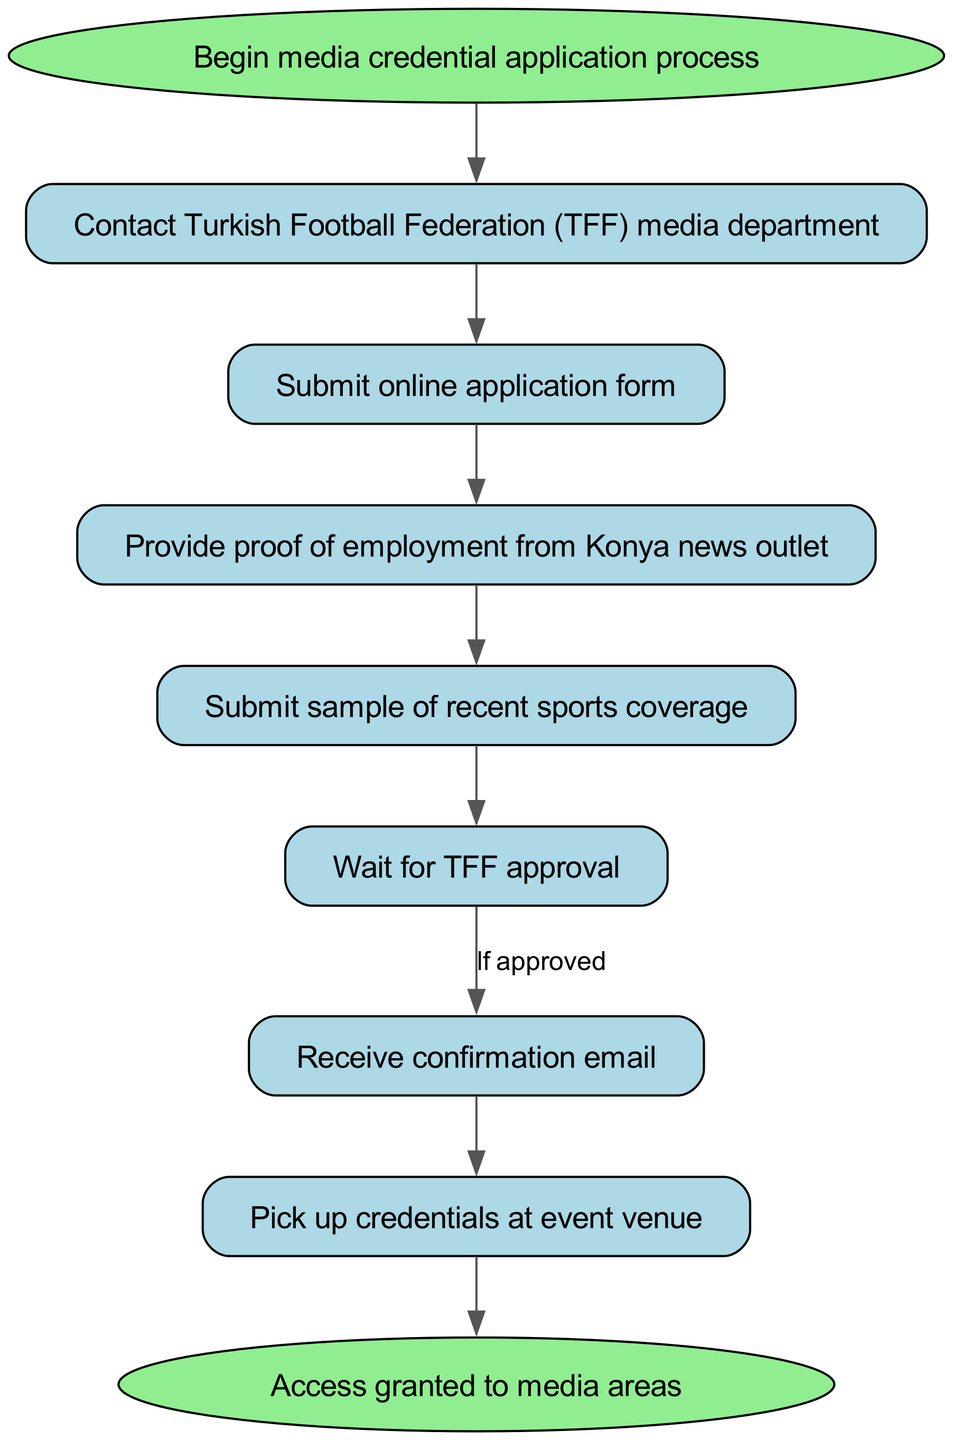What is the first step in the media credential application process? The first step is labeled "Begin media credential application process," which is represented by a starting node in the diagram.
Answer: Begin media credential application process How many nodes are there in the diagram? The diagram consists of 8 nodes, including the start and end nodes, and the 6 intermediary steps for the credential application process.
Answer: 8 What must be done immediately after contacting the TFF media department? After contacting the TFF media department, the next step is to "Submit online application form," which is directed by an edge connecting these two nodes.
Answer: Submit online application form What do you need to provide after submitting the online application form? According to the flow, after submitting the online application form, the next requirement is to "Provide proof of employment from Konya news outlet." This indicates the sequence of necessary actions.
Answer: Provide proof of employment from Konya news outlet What happens after receiving the confirmation email? The process continues with the step "Pick up credentials at event venue," which is a direct action following the receipt of the confirmation email.
Answer: Pick up credentials at event venue What is conditional in the process? The process involves a conditional step where it states "If approved" after waiting for TFF approval, leading to receiving a confirmation email. This indicates the dependency on approval before proceeding.
Answer: If approved In which step do you need to submit a sample? The requirement to "Submit sample of recent sports coverage" occurs after providing proof of employment, according to the flow of steps laid out in the diagram.
Answer: Submit sample of recent sports coverage What signifies the completion of the application process? The process is complete when you reach the end node, which states "Access granted to media areas," indicating successful completion and access approval.
Answer: Access granted to media areas 